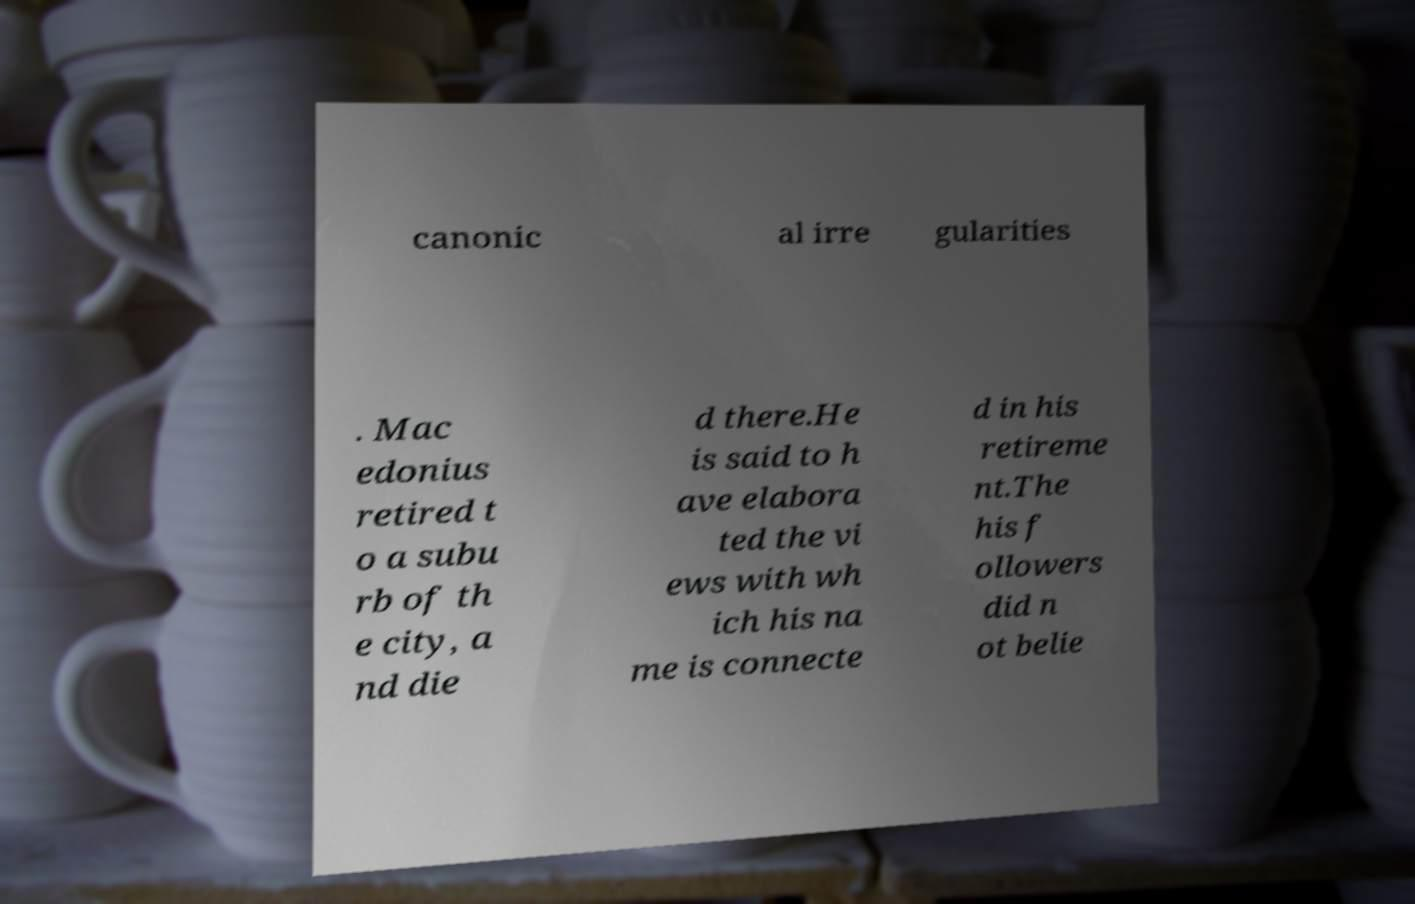For documentation purposes, I need the text within this image transcribed. Could you provide that? canonic al irre gularities . Mac edonius retired t o a subu rb of th e city, a nd die d there.He is said to h ave elabora ted the vi ews with wh ich his na me is connecte d in his retireme nt.The his f ollowers did n ot belie 